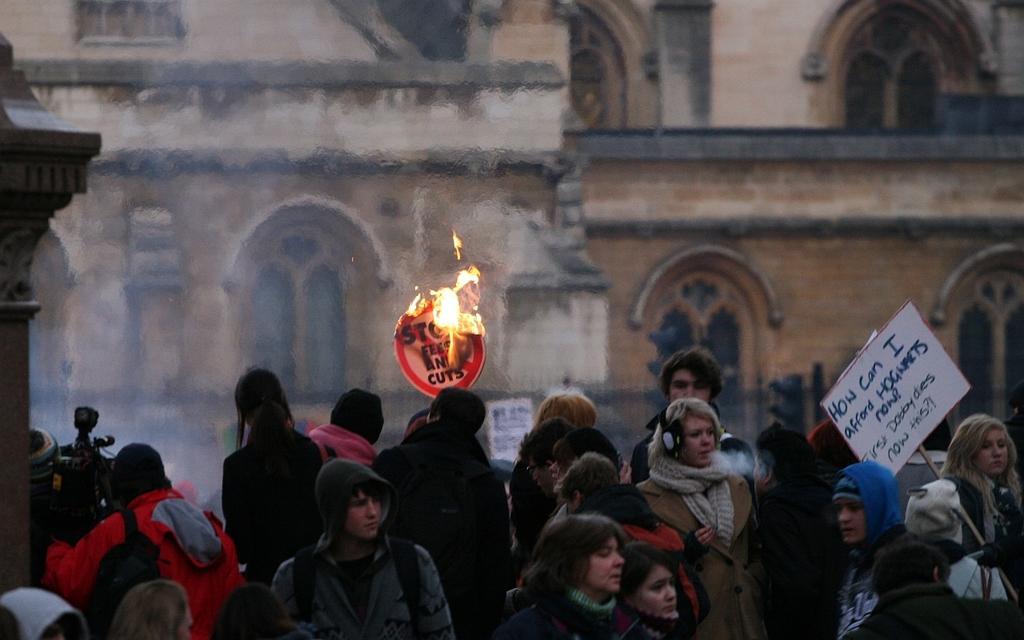Describe this image in one or two sentences. There are people and we can see boards and fire. In the background we can see building and smoke. 